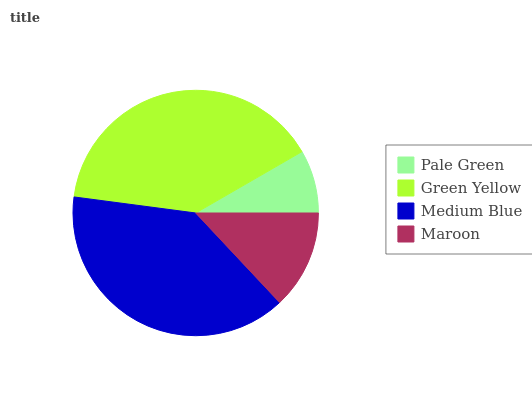Is Pale Green the minimum?
Answer yes or no. Yes. Is Green Yellow the maximum?
Answer yes or no. Yes. Is Medium Blue the minimum?
Answer yes or no. No. Is Medium Blue the maximum?
Answer yes or no. No. Is Green Yellow greater than Medium Blue?
Answer yes or no. Yes. Is Medium Blue less than Green Yellow?
Answer yes or no. Yes. Is Medium Blue greater than Green Yellow?
Answer yes or no. No. Is Green Yellow less than Medium Blue?
Answer yes or no. No. Is Medium Blue the high median?
Answer yes or no. Yes. Is Maroon the low median?
Answer yes or no. Yes. Is Maroon the high median?
Answer yes or no. No. Is Green Yellow the low median?
Answer yes or no. No. 